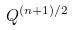<formula> <loc_0><loc_0><loc_500><loc_500>Q ^ { ( n + 1 ) / 2 }</formula> 